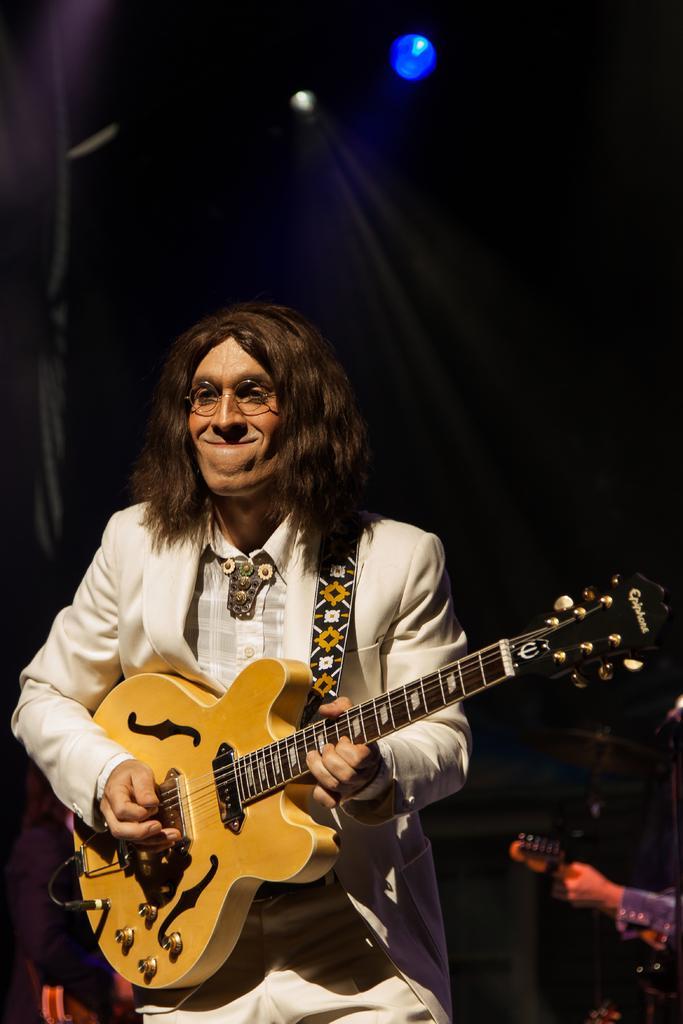Describe this image in one or two sentences. a person is standing wearing a white suit and playing guitar. behind him there is another person at the right. at the back there is black background and on the top there is blue light. 